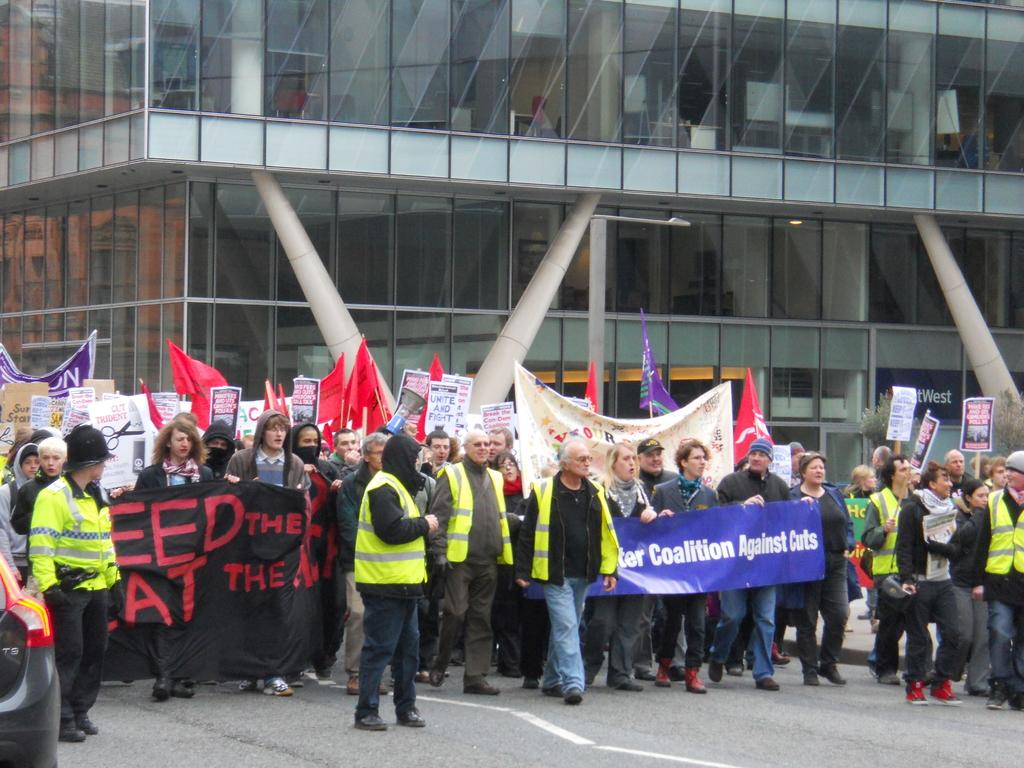What is happening in the middle of the image? There are three men walking in the middle of the image. What are the three men wearing? The men are wearing green coats. Can you describe the people behind the three men? Some of the people behind the men are holding placards and banners. What is visible in the background of the image? There is a glass building in the background of the image. What type of meal is being served at the airport in the image? There is no airport or meal present in the image; it features three men walking and people holding placards and banners. Can you tell me the order in which the people are holding the banners in the image? There is no specific order mentioned or visible in the image; people are simply holding banners and placards. 